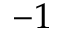Convert formula to latex. <formula><loc_0><loc_0><loc_500><loc_500>- 1</formula> 